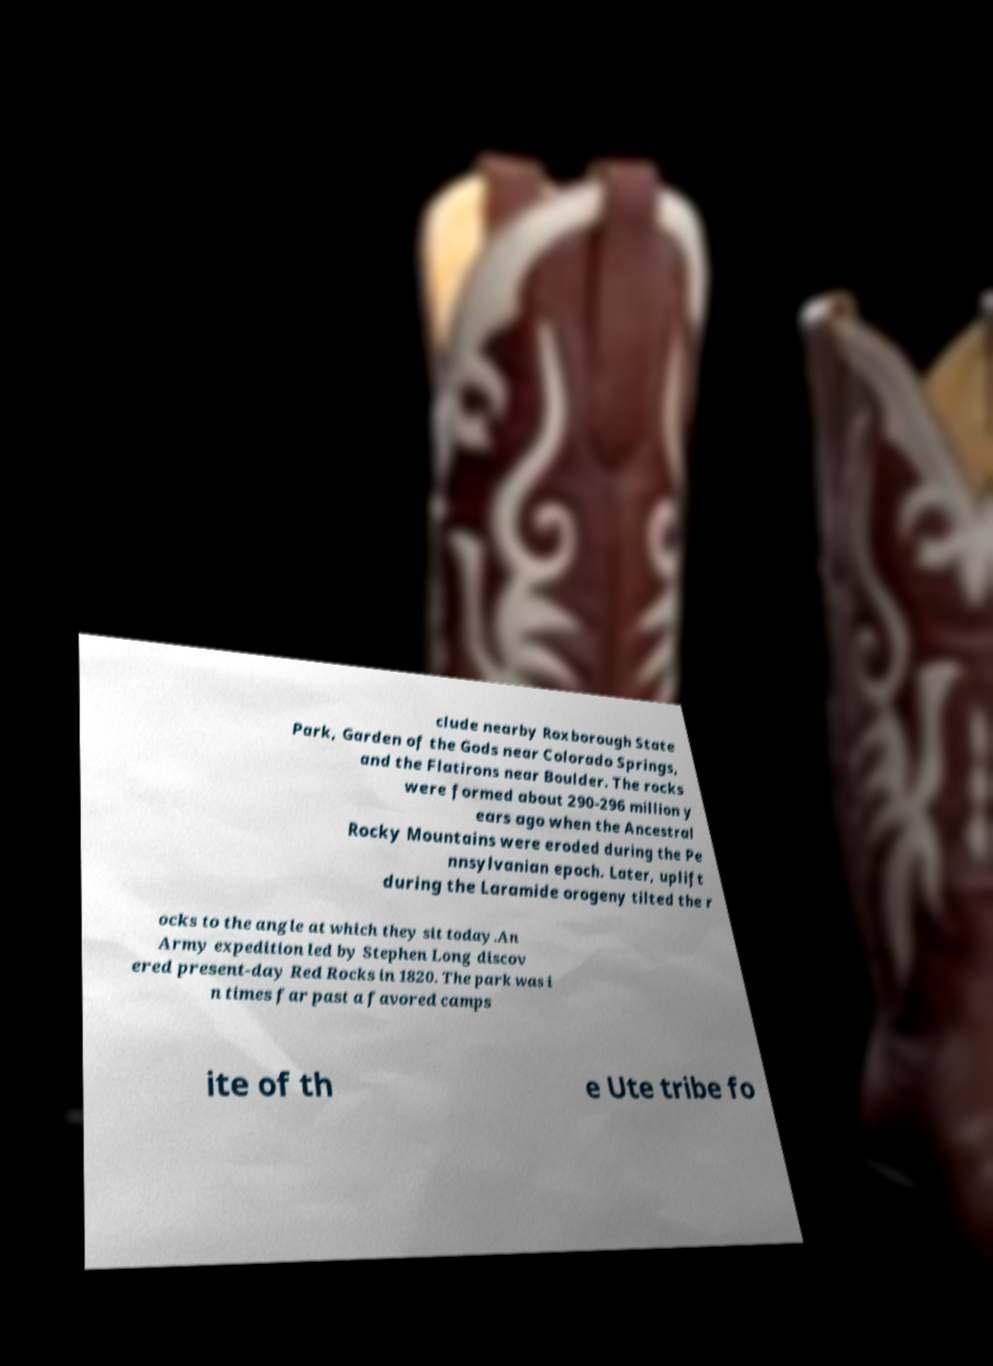For documentation purposes, I need the text within this image transcribed. Could you provide that? clude nearby Roxborough State Park, Garden of the Gods near Colorado Springs, and the Flatirons near Boulder. The rocks were formed about 290-296 million y ears ago when the Ancestral Rocky Mountains were eroded during the Pe nnsylvanian epoch. Later, uplift during the Laramide orogeny tilted the r ocks to the angle at which they sit today.An Army expedition led by Stephen Long discov ered present-day Red Rocks in 1820. The park was i n times far past a favored camps ite of th e Ute tribe fo 